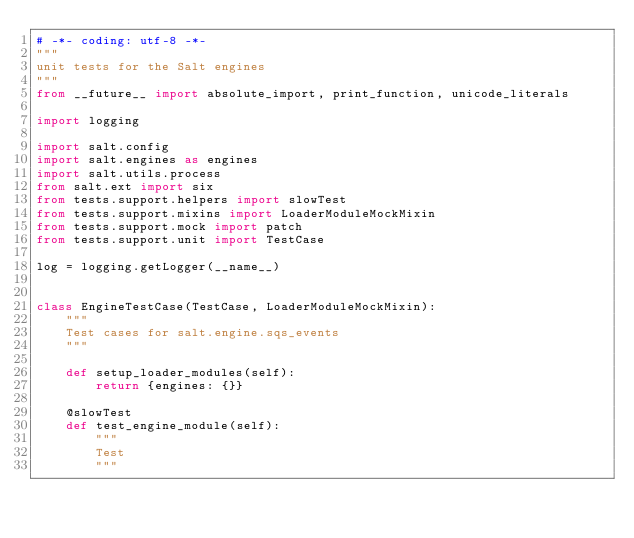<code> <loc_0><loc_0><loc_500><loc_500><_Python_># -*- coding: utf-8 -*-
"""
unit tests for the Salt engines
"""
from __future__ import absolute_import, print_function, unicode_literals

import logging

import salt.config
import salt.engines as engines
import salt.utils.process
from salt.ext import six
from tests.support.helpers import slowTest
from tests.support.mixins import LoaderModuleMockMixin
from tests.support.mock import patch
from tests.support.unit import TestCase

log = logging.getLogger(__name__)


class EngineTestCase(TestCase, LoaderModuleMockMixin):
    """
    Test cases for salt.engine.sqs_events
    """

    def setup_loader_modules(self):
        return {engines: {}}

    @slowTest
    def test_engine_module(self):
        """
        Test
        """</code> 